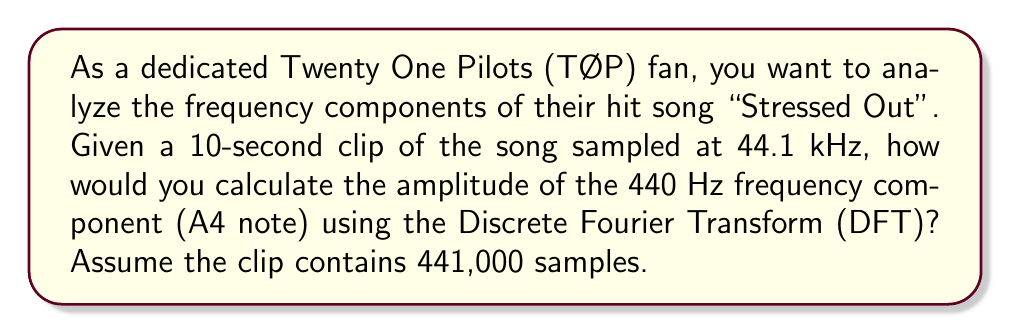Can you answer this question? To calculate the amplitude of the 440 Hz frequency component using the Discrete Fourier Transform (DFT), we'll follow these steps:

1. Understand the DFT formula:
   The DFT of a discrete signal $x[n]$ of length $N$ is given by:
   
   $$X[k] = \sum_{n=0}^{N-1} x[n] e^{-j2\pi kn/N}$$

   where $k = 0, 1, ..., N-1$ represents the frequency bin.

2. Determine the frequency resolution:
   The frequency resolution $\Delta f$ is given by:
   
   $$\Delta f = \frac{f_s}{N}$$
   
   where $f_s$ is the sampling frequency and $N$ is the number of samples.
   
   $$\Delta f = \frac{44100}{441000} = 0.1 \text{ Hz}$$

3. Find the bin number $k$ for 440 Hz:
   
   $$k = \frac{440}{\Delta f} = \frac{440}{0.1} = 4400$$

4. Calculate the DFT at $k = 4400$:
   
   $$X[4400] = \sum_{n=0}^{441000-1} x[n] e^{-j2\pi (4400)n/441000}$$

5. The magnitude of $X[4400]$ gives the amplitude of the 440 Hz component:
   
   $$\text{Amplitude} = |X[4400]| = \sqrt{\text{Re}(X[4400])^2 + \text{Im}(X[4400])^2}$$

In practice, you would use a Fast Fourier Transform (FFT) algorithm to efficiently compute the DFT, as direct computation is computationally intensive for large N.
Answer: The amplitude of the 440 Hz frequency component is $|X[4400]|$, where $X[4400]$ is the 4400th bin of the DFT of the input signal. 